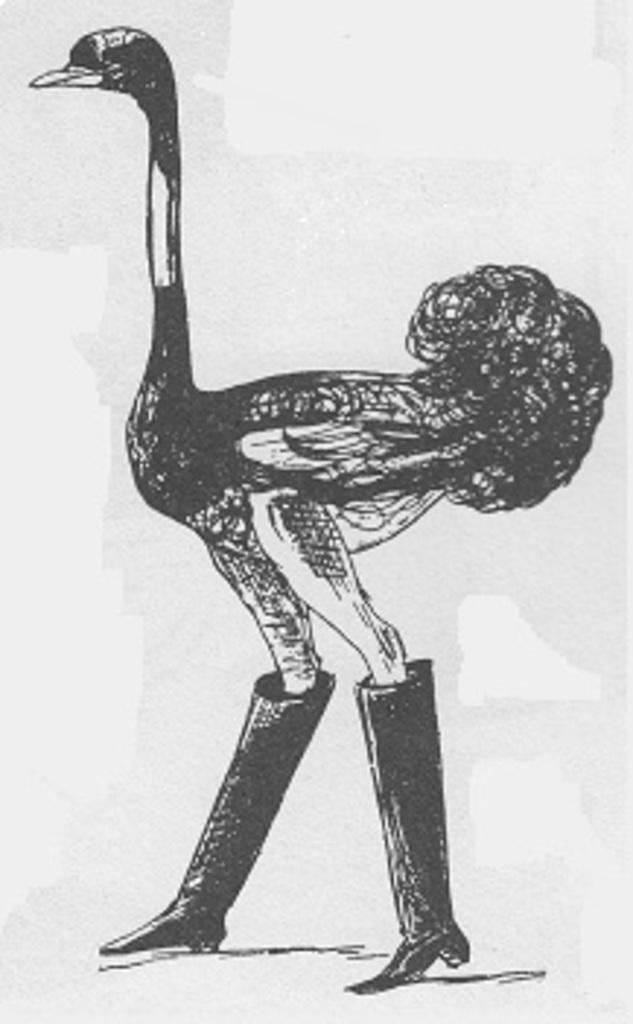Describe this image in one or two sentences. This is a drawing, in this image in the center there is one ostrich, and the ostrich is wearing some shoes. 